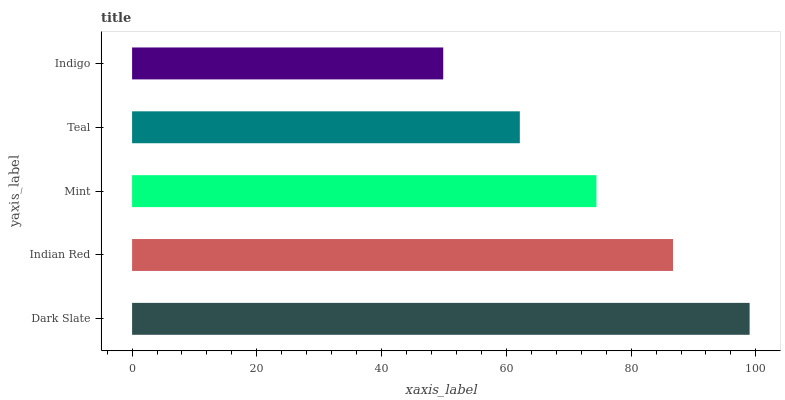Is Indigo the minimum?
Answer yes or no. Yes. Is Dark Slate the maximum?
Answer yes or no. Yes. Is Indian Red the minimum?
Answer yes or no. No. Is Indian Red the maximum?
Answer yes or no. No. Is Dark Slate greater than Indian Red?
Answer yes or no. Yes. Is Indian Red less than Dark Slate?
Answer yes or no. Yes. Is Indian Red greater than Dark Slate?
Answer yes or no. No. Is Dark Slate less than Indian Red?
Answer yes or no. No. Is Mint the high median?
Answer yes or no. Yes. Is Mint the low median?
Answer yes or no. Yes. Is Teal the high median?
Answer yes or no. No. Is Indigo the low median?
Answer yes or no. No. 